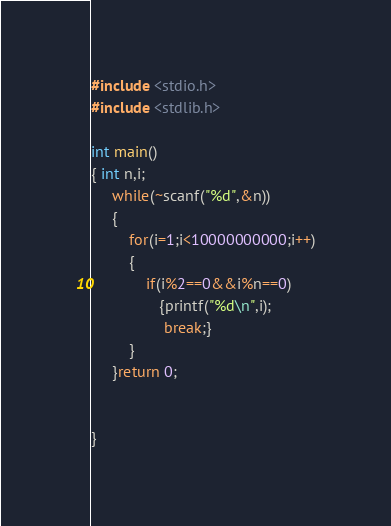Convert code to text. <code><loc_0><loc_0><loc_500><loc_500><_C_>#include <stdio.h>
#include <stdlib.h>

int main()
{ int n,i;
     while(~scanf("%d",&n))
     {
         for(i=1;i<10000000000;i++)
         {
             if(i%2==0&&i%n==0)
                {printf("%d\n",i);
                 break;}
         }
     }return 0;


}
</code> 